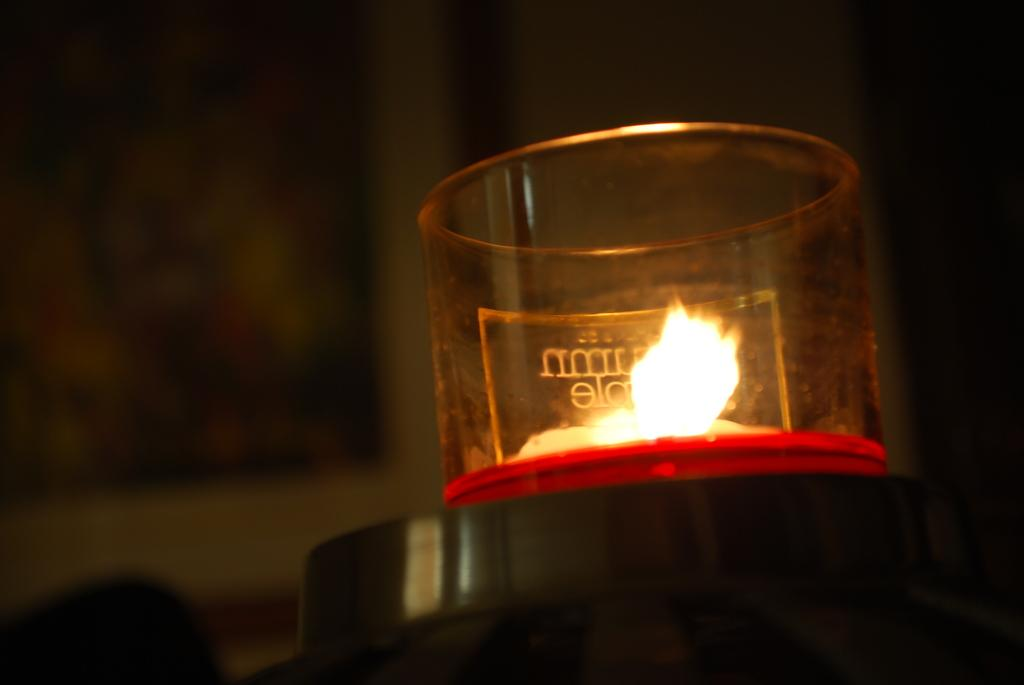What is the main object in the image? There is an object with a glass container in the image. What is happening inside the glass container? There is a flame in the glass container. Can you describe the background of the image? The background of the image is blurred. Who is the manager of the invention depicted in the image? There is no invention or manager mentioned in the image. Can you tell me how many tents are visible in the image? There are no tents present in the image. 